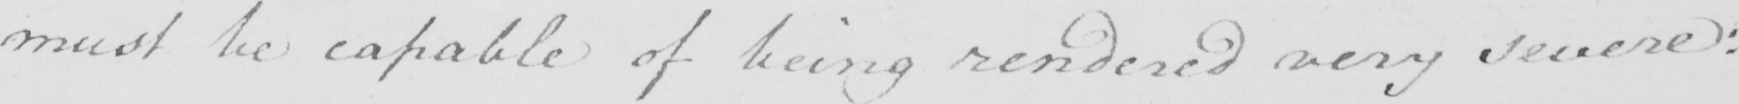Can you tell me what this handwritten text says? must be capable of being rendered very severe : 